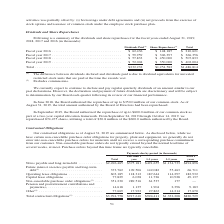From Jabil Circuit's financial document, Which fiscal years does the table provide data of the dividends and share repurchases for? The document contains multiple relevant values: 2016, 2017, 2018, 2019. From the document: "for the fiscal years ended August 31, 2019, 2018, 2017 and 2016 (in thousands): iscal years ended August 31, 2019, 2018, 2017 and 2016 (in thousands):..." Also, What were the dividends paid in 2016? According to the financial document, $62,436 (in thousands). The relevant text states: "Fiscal year 2016 . $ 62,436 $ 148,185 $ 210,621 Fiscal year 2017 . $ 59,959 $ 306,397 $ 366,356 Fiscal year 2018 . $ 57,833 $ 4..." Also, What were the share repurchases in 2017? According to the financial document, $306,397 (in thousands). The relevant text states: "$ 148,185 $ 210,621 Fiscal year 2017 . $ 59,959 $ 306,397 $ 366,356 Fiscal year 2018 . $ 57,833 $ 450,000 $ 507,833 Fiscal year 2019 . $ 52,004 $ 350,000 $ 4..." Also, How many fiscal years had dividends paid that exceeded $60,000 thousand? Based on the analysis, there are 1 instances. The counting process: 2016. Also, can you calculate: What was the change in share repurchases between 2016 and 2017? Based on the calculation: $306,397-$148,185, the result is 158212 (in thousands). This is based on the information: "Fiscal year 2016 . $ 62,436 $ 148,185 $ 210,621 Fiscal year 2017 . $ 59,959 $ 306,397 $ 366,356 Fiscal year 2018 . $ 57,833 $ 450,000 $ 5 $ 148,185 $ 210,621 Fiscal year 2017 . $ 59,959 $ 306,397 $ 36..." The key data points involved are: 148,185, 306,397. Also, can you calculate: What was the percentage change in dividends paid between 2018 and 2019? To answer this question, I need to perform calculations using the financial data. The calculation is: ($52,004-$57,833)/$57,833, which equals -10.08 (percentage). This is based on the information: "$ 59,959 $ 306,397 $ 366,356 Fiscal year 2018 . $ 57,833 $ 450,000 $ 507,833 Fiscal year 2019 . $ 52,004 $ 350,000 $ 402,004 $ 57,833 $ 450,000 $ 507,833 Fiscal year 2019 . $ 52,004 $ 350,000 $ 402,00..." The key data points involved are: 52,004, 57,833. 